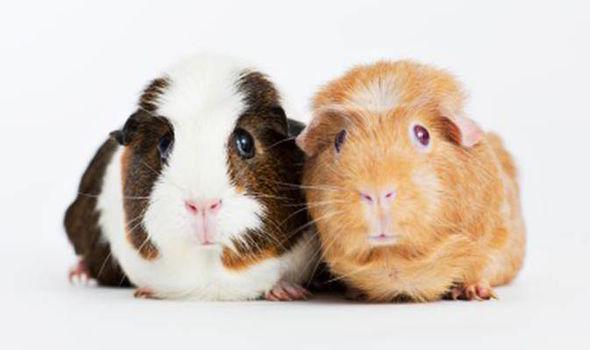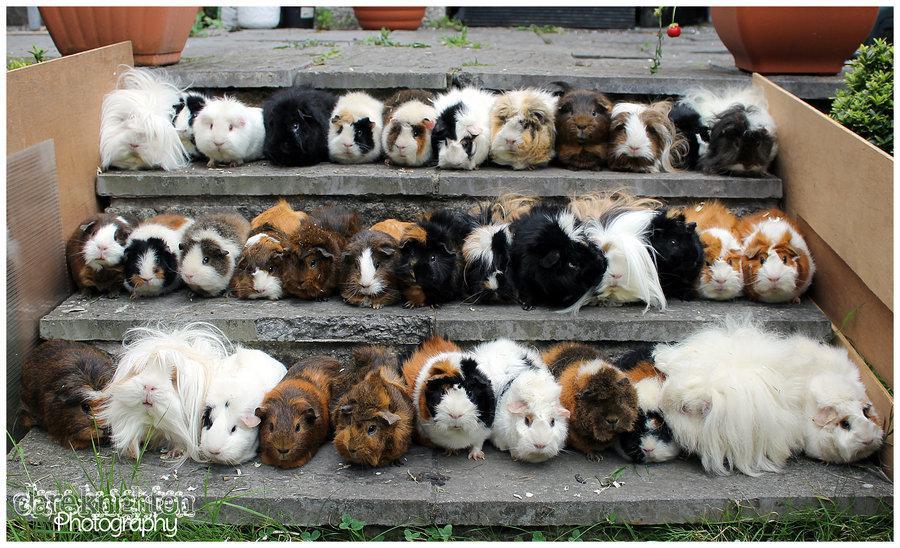The first image is the image on the left, the second image is the image on the right. For the images shown, is this caption "One image contains only two guinea pigs." true? Answer yes or no. Yes. The first image is the image on the left, the second image is the image on the right. Assess this claim about the two images: "An image shows exactly two hamsters side by side.". Correct or not? Answer yes or no. Yes. 